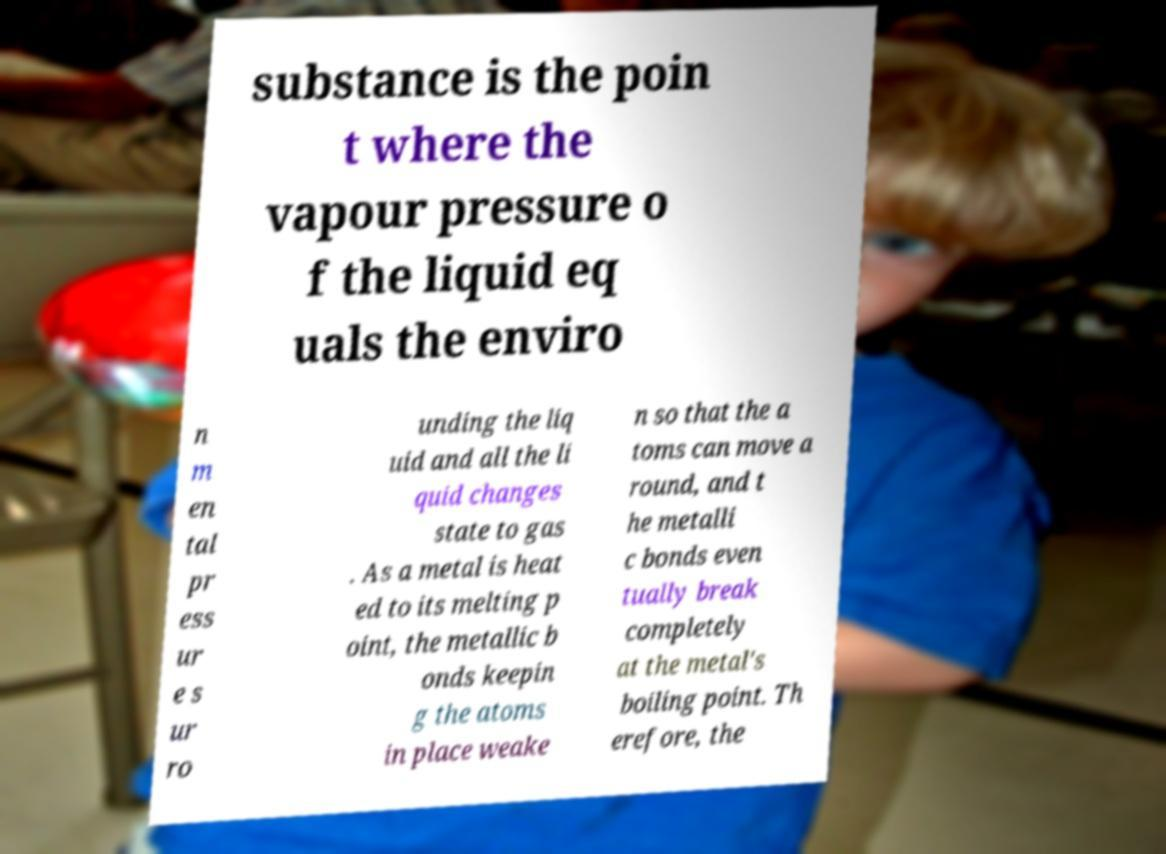Can you read and provide the text displayed in the image?This photo seems to have some interesting text. Can you extract and type it out for me? substance is the poin t where the vapour pressure o f the liquid eq uals the enviro n m en tal pr ess ur e s ur ro unding the liq uid and all the li quid changes state to gas . As a metal is heat ed to its melting p oint, the metallic b onds keepin g the atoms in place weake n so that the a toms can move a round, and t he metalli c bonds even tually break completely at the metal's boiling point. Th erefore, the 